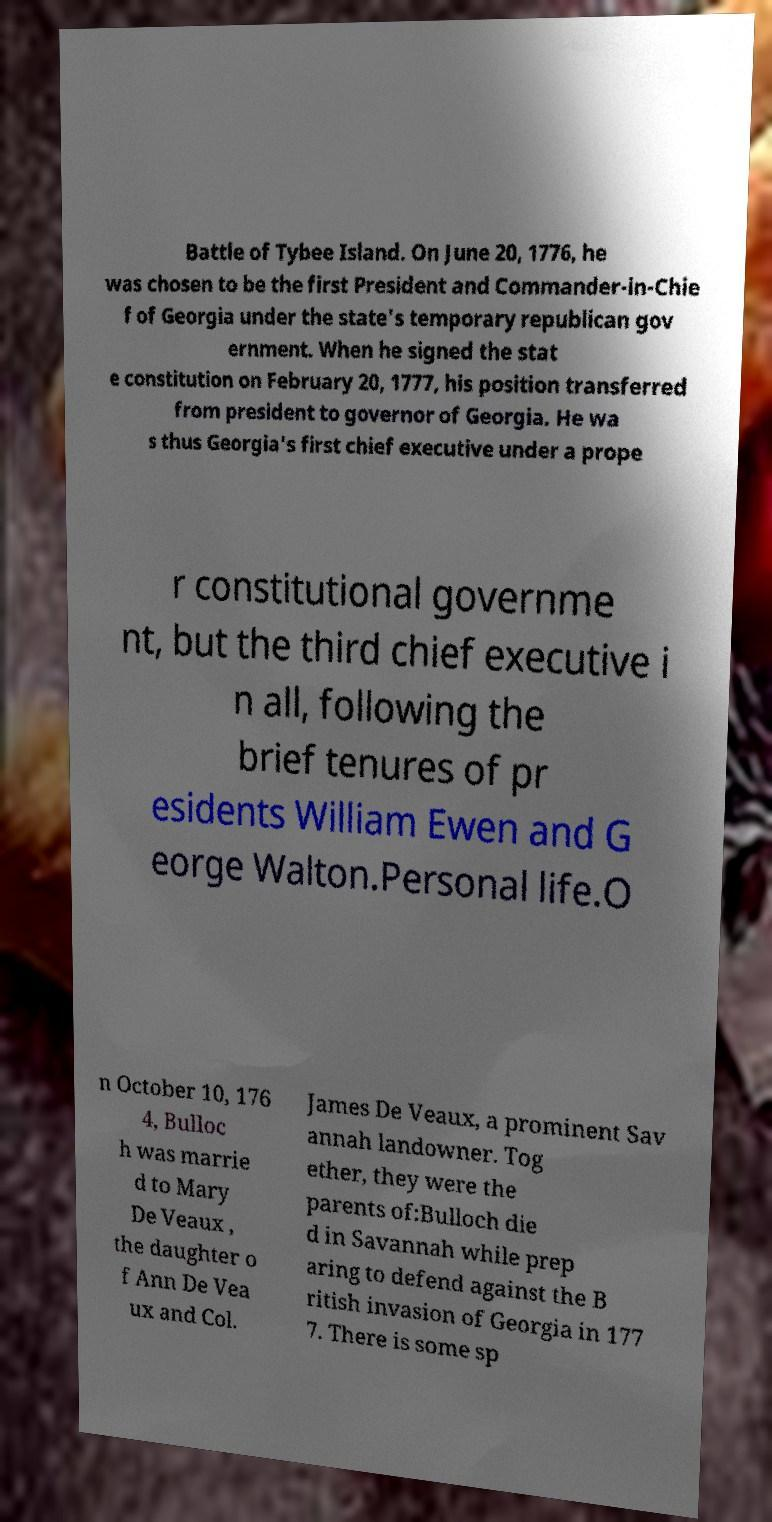Please identify and transcribe the text found in this image. Battle of Tybee Island. On June 20, 1776, he was chosen to be the first President and Commander-in-Chie f of Georgia under the state's temporary republican gov ernment. When he signed the stat e constitution on February 20, 1777, his position transferred from president to governor of Georgia. He wa s thus Georgia's first chief executive under a prope r constitutional governme nt, but the third chief executive i n all, following the brief tenures of pr esidents William Ewen and G eorge Walton.Personal life.O n October 10, 176 4, Bulloc h was marrie d to Mary De Veaux , the daughter o f Ann De Vea ux and Col. James De Veaux, a prominent Sav annah landowner. Tog ether, they were the parents of:Bulloch die d in Savannah while prep aring to defend against the B ritish invasion of Georgia in 177 7. There is some sp 